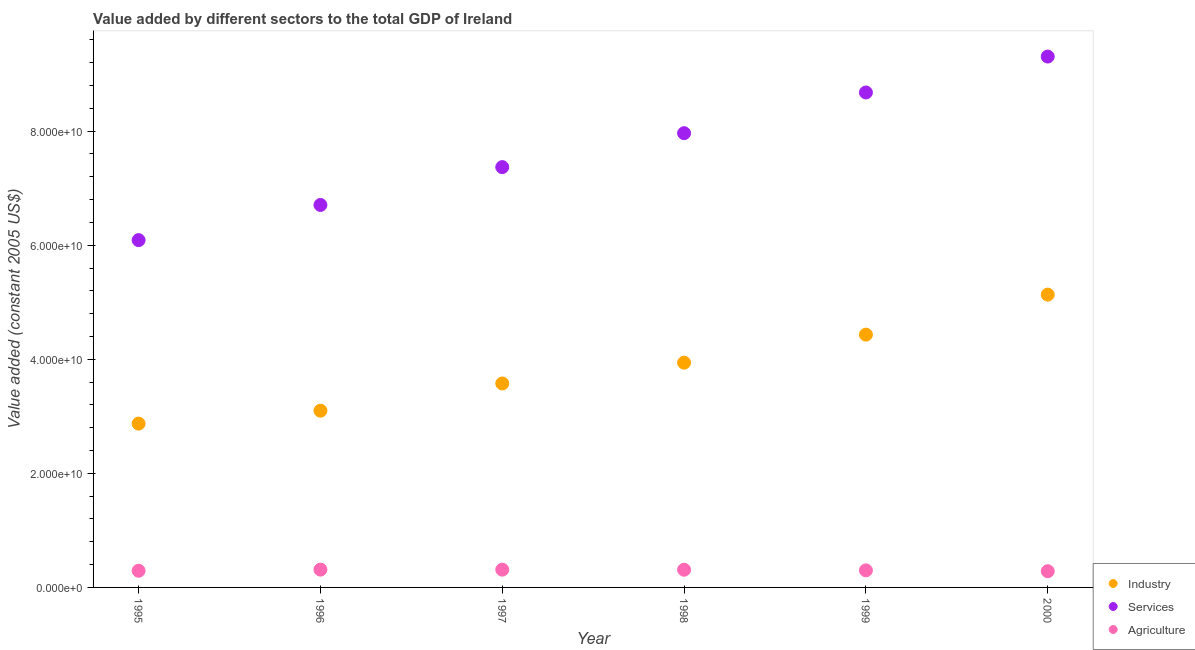What is the value added by industrial sector in 1995?
Provide a succinct answer. 2.87e+1. Across all years, what is the maximum value added by agricultural sector?
Offer a terse response. 3.12e+09. Across all years, what is the minimum value added by services?
Offer a terse response. 6.09e+1. What is the total value added by services in the graph?
Your answer should be compact. 4.61e+11. What is the difference between the value added by industrial sector in 1997 and that in 2000?
Your response must be concise. -1.56e+1. What is the difference between the value added by services in 1998 and the value added by agricultural sector in 1996?
Your answer should be compact. 7.65e+1. What is the average value added by industrial sector per year?
Provide a short and direct response. 3.84e+1. In the year 1995, what is the difference between the value added by industrial sector and value added by services?
Your answer should be very brief. -3.22e+1. In how many years, is the value added by agricultural sector greater than 4000000000 US$?
Give a very brief answer. 0. What is the ratio of the value added by agricultural sector in 1995 to that in 1997?
Ensure brevity in your answer.  0.94. What is the difference between the highest and the second highest value added by industrial sector?
Offer a terse response. 7.01e+09. What is the difference between the highest and the lowest value added by services?
Your response must be concise. 3.22e+1. In how many years, is the value added by services greater than the average value added by services taken over all years?
Your answer should be very brief. 3. Is it the case that in every year, the sum of the value added by industrial sector and value added by services is greater than the value added by agricultural sector?
Make the answer very short. Yes. Does the value added by services monotonically increase over the years?
Offer a very short reply. Yes. Is the value added by industrial sector strictly greater than the value added by agricultural sector over the years?
Your response must be concise. Yes. How many years are there in the graph?
Make the answer very short. 6. What is the difference between two consecutive major ticks on the Y-axis?
Make the answer very short. 2.00e+1. How many legend labels are there?
Your answer should be compact. 3. How are the legend labels stacked?
Your answer should be very brief. Vertical. What is the title of the graph?
Provide a succinct answer. Value added by different sectors to the total GDP of Ireland. What is the label or title of the X-axis?
Keep it short and to the point. Year. What is the label or title of the Y-axis?
Keep it short and to the point. Value added (constant 2005 US$). What is the Value added (constant 2005 US$) in Industry in 1995?
Ensure brevity in your answer.  2.87e+1. What is the Value added (constant 2005 US$) of Services in 1995?
Your answer should be very brief. 6.09e+1. What is the Value added (constant 2005 US$) of Agriculture in 1995?
Keep it short and to the point. 2.92e+09. What is the Value added (constant 2005 US$) in Industry in 1996?
Your answer should be very brief. 3.10e+1. What is the Value added (constant 2005 US$) in Services in 1996?
Provide a succinct answer. 6.71e+1. What is the Value added (constant 2005 US$) in Agriculture in 1996?
Offer a terse response. 3.12e+09. What is the Value added (constant 2005 US$) in Industry in 1997?
Your answer should be compact. 3.58e+1. What is the Value added (constant 2005 US$) in Services in 1997?
Keep it short and to the point. 7.37e+1. What is the Value added (constant 2005 US$) of Agriculture in 1997?
Provide a short and direct response. 3.12e+09. What is the Value added (constant 2005 US$) of Industry in 1998?
Your answer should be very brief. 3.94e+1. What is the Value added (constant 2005 US$) of Services in 1998?
Give a very brief answer. 7.96e+1. What is the Value added (constant 2005 US$) in Agriculture in 1998?
Your answer should be compact. 3.10e+09. What is the Value added (constant 2005 US$) in Industry in 1999?
Keep it short and to the point. 4.43e+1. What is the Value added (constant 2005 US$) of Services in 1999?
Ensure brevity in your answer.  8.68e+1. What is the Value added (constant 2005 US$) of Agriculture in 1999?
Offer a very short reply. 2.99e+09. What is the Value added (constant 2005 US$) in Industry in 2000?
Provide a succinct answer. 5.13e+1. What is the Value added (constant 2005 US$) in Services in 2000?
Provide a succinct answer. 9.31e+1. What is the Value added (constant 2005 US$) of Agriculture in 2000?
Your response must be concise. 2.85e+09. Across all years, what is the maximum Value added (constant 2005 US$) in Industry?
Provide a short and direct response. 5.13e+1. Across all years, what is the maximum Value added (constant 2005 US$) in Services?
Ensure brevity in your answer.  9.31e+1. Across all years, what is the maximum Value added (constant 2005 US$) in Agriculture?
Your answer should be very brief. 3.12e+09. Across all years, what is the minimum Value added (constant 2005 US$) in Industry?
Provide a succinct answer. 2.87e+1. Across all years, what is the minimum Value added (constant 2005 US$) of Services?
Provide a short and direct response. 6.09e+1. Across all years, what is the minimum Value added (constant 2005 US$) of Agriculture?
Provide a succinct answer. 2.85e+09. What is the total Value added (constant 2005 US$) in Industry in the graph?
Your response must be concise. 2.31e+11. What is the total Value added (constant 2005 US$) in Services in the graph?
Give a very brief answer. 4.61e+11. What is the total Value added (constant 2005 US$) of Agriculture in the graph?
Your answer should be very brief. 1.81e+1. What is the difference between the Value added (constant 2005 US$) of Industry in 1995 and that in 1996?
Provide a short and direct response. -2.26e+09. What is the difference between the Value added (constant 2005 US$) of Services in 1995 and that in 1996?
Offer a very short reply. -6.16e+09. What is the difference between the Value added (constant 2005 US$) of Agriculture in 1995 and that in 1996?
Offer a terse response. -2.00e+08. What is the difference between the Value added (constant 2005 US$) in Industry in 1995 and that in 1997?
Keep it short and to the point. -7.04e+09. What is the difference between the Value added (constant 2005 US$) of Services in 1995 and that in 1997?
Make the answer very short. -1.28e+1. What is the difference between the Value added (constant 2005 US$) of Agriculture in 1995 and that in 1997?
Offer a very short reply. -1.97e+08. What is the difference between the Value added (constant 2005 US$) of Industry in 1995 and that in 1998?
Your answer should be very brief. -1.07e+1. What is the difference between the Value added (constant 2005 US$) of Services in 1995 and that in 1998?
Give a very brief answer. -1.87e+1. What is the difference between the Value added (constant 2005 US$) of Agriculture in 1995 and that in 1998?
Your answer should be compact. -1.81e+08. What is the difference between the Value added (constant 2005 US$) in Industry in 1995 and that in 1999?
Offer a very short reply. -1.56e+1. What is the difference between the Value added (constant 2005 US$) of Services in 1995 and that in 1999?
Give a very brief answer. -2.59e+1. What is the difference between the Value added (constant 2005 US$) in Agriculture in 1995 and that in 1999?
Keep it short and to the point. -7.07e+07. What is the difference between the Value added (constant 2005 US$) in Industry in 1995 and that in 2000?
Give a very brief answer. -2.26e+1. What is the difference between the Value added (constant 2005 US$) of Services in 1995 and that in 2000?
Give a very brief answer. -3.22e+1. What is the difference between the Value added (constant 2005 US$) in Agriculture in 1995 and that in 2000?
Offer a very short reply. 7.59e+07. What is the difference between the Value added (constant 2005 US$) of Industry in 1996 and that in 1997?
Keep it short and to the point. -4.77e+09. What is the difference between the Value added (constant 2005 US$) in Services in 1996 and that in 1997?
Give a very brief answer. -6.64e+09. What is the difference between the Value added (constant 2005 US$) in Agriculture in 1996 and that in 1997?
Keep it short and to the point. 3.65e+06. What is the difference between the Value added (constant 2005 US$) of Industry in 1996 and that in 1998?
Your response must be concise. -8.42e+09. What is the difference between the Value added (constant 2005 US$) in Services in 1996 and that in 1998?
Offer a very short reply. -1.26e+1. What is the difference between the Value added (constant 2005 US$) of Agriculture in 1996 and that in 1998?
Ensure brevity in your answer.  1.94e+07. What is the difference between the Value added (constant 2005 US$) in Industry in 1996 and that in 1999?
Give a very brief answer. -1.33e+1. What is the difference between the Value added (constant 2005 US$) of Services in 1996 and that in 1999?
Offer a very short reply. -1.97e+1. What is the difference between the Value added (constant 2005 US$) of Agriculture in 1996 and that in 1999?
Make the answer very short. 1.30e+08. What is the difference between the Value added (constant 2005 US$) in Industry in 1996 and that in 2000?
Provide a short and direct response. -2.03e+1. What is the difference between the Value added (constant 2005 US$) of Services in 1996 and that in 2000?
Make the answer very short. -2.60e+1. What is the difference between the Value added (constant 2005 US$) in Agriculture in 1996 and that in 2000?
Your answer should be compact. 2.76e+08. What is the difference between the Value added (constant 2005 US$) of Industry in 1997 and that in 1998?
Your response must be concise. -3.65e+09. What is the difference between the Value added (constant 2005 US$) in Services in 1997 and that in 1998?
Keep it short and to the point. -5.95e+09. What is the difference between the Value added (constant 2005 US$) in Agriculture in 1997 and that in 1998?
Provide a short and direct response. 1.58e+07. What is the difference between the Value added (constant 2005 US$) of Industry in 1997 and that in 1999?
Make the answer very short. -8.56e+09. What is the difference between the Value added (constant 2005 US$) in Services in 1997 and that in 1999?
Give a very brief answer. -1.31e+1. What is the difference between the Value added (constant 2005 US$) in Agriculture in 1997 and that in 1999?
Give a very brief answer. 1.26e+08. What is the difference between the Value added (constant 2005 US$) of Industry in 1997 and that in 2000?
Provide a succinct answer. -1.56e+1. What is the difference between the Value added (constant 2005 US$) in Services in 1997 and that in 2000?
Your answer should be compact. -1.94e+1. What is the difference between the Value added (constant 2005 US$) of Agriculture in 1997 and that in 2000?
Offer a very short reply. 2.72e+08. What is the difference between the Value added (constant 2005 US$) in Industry in 1998 and that in 1999?
Your answer should be very brief. -4.91e+09. What is the difference between the Value added (constant 2005 US$) in Services in 1998 and that in 1999?
Your answer should be compact. -7.14e+09. What is the difference between the Value added (constant 2005 US$) in Agriculture in 1998 and that in 1999?
Give a very brief answer. 1.10e+08. What is the difference between the Value added (constant 2005 US$) of Industry in 1998 and that in 2000?
Keep it short and to the point. -1.19e+1. What is the difference between the Value added (constant 2005 US$) of Services in 1998 and that in 2000?
Make the answer very short. -1.34e+1. What is the difference between the Value added (constant 2005 US$) of Agriculture in 1998 and that in 2000?
Your response must be concise. 2.57e+08. What is the difference between the Value added (constant 2005 US$) of Industry in 1999 and that in 2000?
Keep it short and to the point. -7.01e+09. What is the difference between the Value added (constant 2005 US$) in Services in 1999 and that in 2000?
Ensure brevity in your answer.  -6.30e+09. What is the difference between the Value added (constant 2005 US$) of Agriculture in 1999 and that in 2000?
Provide a succinct answer. 1.47e+08. What is the difference between the Value added (constant 2005 US$) of Industry in 1995 and the Value added (constant 2005 US$) of Services in 1996?
Provide a short and direct response. -3.83e+1. What is the difference between the Value added (constant 2005 US$) in Industry in 1995 and the Value added (constant 2005 US$) in Agriculture in 1996?
Provide a short and direct response. 2.56e+1. What is the difference between the Value added (constant 2005 US$) in Services in 1995 and the Value added (constant 2005 US$) in Agriculture in 1996?
Make the answer very short. 5.78e+1. What is the difference between the Value added (constant 2005 US$) of Industry in 1995 and the Value added (constant 2005 US$) of Services in 1997?
Your answer should be compact. -4.50e+1. What is the difference between the Value added (constant 2005 US$) of Industry in 1995 and the Value added (constant 2005 US$) of Agriculture in 1997?
Keep it short and to the point. 2.56e+1. What is the difference between the Value added (constant 2005 US$) of Services in 1995 and the Value added (constant 2005 US$) of Agriculture in 1997?
Ensure brevity in your answer.  5.78e+1. What is the difference between the Value added (constant 2005 US$) of Industry in 1995 and the Value added (constant 2005 US$) of Services in 1998?
Your answer should be compact. -5.09e+1. What is the difference between the Value added (constant 2005 US$) in Industry in 1995 and the Value added (constant 2005 US$) in Agriculture in 1998?
Your answer should be very brief. 2.56e+1. What is the difference between the Value added (constant 2005 US$) in Services in 1995 and the Value added (constant 2005 US$) in Agriculture in 1998?
Ensure brevity in your answer.  5.78e+1. What is the difference between the Value added (constant 2005 US$) of Industry in 1995 and the Value added (constant 2005 US$) of Services in 1999?
Offer a terse response. -5.81e+1. What is the difference between the Value added (constant 2005 US$) of Industry in 1995 and the Value added (constant 2005 US$) of Agriculture in 1999?
Provide a short and direct response. 2.57e+1. What is the difference between the Value added (constant 2005 US$) of Services in 1995 and the Value added (constant 2005 US$) of Agriculture in 1999?
Ensure brevity in your answer.  5.79e+1. What is the difference between the Value added (constant 2005 US$) of Industry in 1995 and the Value added (constant 2005 US$) of Services in 2000?
Provide a succinct answer. -6.44e+1. What is the difference between the Value added (constant 2005 US$) in Industry in 1995 and the Value added (constant 2005 US$) in Agriculture in 2000?
Give a very brief answer. 2.59e+1. What is the difference between the Value added (constant 2005 US$) of Services in 1995 and the Value added (constant 2005 US$) of Agriculture in 2000?
Offer a very short reply. 5.80e+1. What is the difference between the Value added (constant 2005 US$) in Industry in 1996 and the Value added (constant 2005 US$) in Services in 1997?
Give a very brief answer. -4.27e+1. What is the difference between the Value added (constant 2005 US$) in Industry in 1996 and the Value added (constant 2005 US$) in Agriculture in 1997?
Make the answer very short. 2.79e+1. What is the difference between the Value added (constant 2005 US$) of Services in 1996 and the Value added (constant 2005 US$) of Agriculture in 1997?
Provide a short and direct response. 6.39e+1. What is the difference between the Value added (constant 2005 US$) in Industry in 1996 and the Value added (constant 2005 US$) in Services in 1998?
Provide a succinct answer. -4.87e+1. What is the difference between the Value added (constant 2005 US$) in Industry in 1996 and the Value added (constant 2005 US$) in Agriculture in 1998?
Keep it short and to the point. 2.79e+1. What is the difference between the Value added (constant 2005 US$) of Services in 1996 and the Value added (constant 2005 US$) of Agriculture in 1998?
Your answer should be compact. 6.40e+1. What is the difference between the Value added (constant 2005 US$) of Industry in 1996 and the Value added (constant 2005 US$) of Services in 1999?
Offer a very short reply. -5.58e+1. What is the difference between the Value added (constant 2005 US$) of Industry in 1996 and the Value added (constant 2005 US$) of Agriculture in 1999?
Provide a short and direct response. 2.80e+1. What is the difference between the Value added (constant 2005 US$) of Services in 1996 and the Value added (constant 2005 US$) of Agriculture in 1999?
Offer a terse response. 6.41e+1. What is the difference between the Value added (constant 2005 US$) of Industry in 1996 and the Value added (constant 2005 US$) of Services in 2000?
Give a very brief answer. -6.21e+1. What is the difference between the Value added (constant 2005 US$) of Industry in 1996 and the Value added (constant 2005 US$) of Agriculture in 2000?
Make the answer very short. 2.81e+1. What is the difference between the Value added (constant 2005 US$) in Services in 1996 and the Value added (constant 2005 US$) in Agriculture in 2000?
Offer a very short reply. 6.42e+1. What is the difference between the Value added (constant 2005 US$) in Industry in 1997 and the Value added (constant 2005 US$) in Services in 1998?
Your answer should be compact. -4.39e+1. What is the difference between the Value added (constant 2005 US$) in Industry in 1997 and the Value added (constant 2005 US$) in Agriculture in 1998?
Give a very brief answer. 3.27e+1. What is the difference between the Value added (constant 2005 US$) in Services in 1997 and the Value added (constant 2005 US$) in Agriculture in 1998?
Keep it short and to the point. 7.06e+1. What is the difference between the Value added (constant 2005 US$) of Industry in 1997 and the Value added (constant 2005 US$) of Services in 1999?
Your answer should be very brief. -5.10e+1. What is the difference between the Value added (constant 2005 US$) in Industry in 1997 and the Value added (constant 2005 US$) in Agriculture in 1999?
Your answer should be compact. 3.28e+1. What is the difference between the Value added (constant 2005 US$) in Services in 1997 and the Value added (constant 2005 US$) in Agriculture in 1999?
Offer a terse response. 7.07e+1. What is the difference between the Value added (constant 2005 US$) of Industry in 1997 and the Value added (constant 2005 US$) of Services in 2000?
Ensure brevity in your answer.  -5.73e+1. What is the difference between the Value added (constant 2005 US$) in Industry in 1997 and the Value added (constant 2005 US$) in Agriculture in 2000?
Keep it short and to the point. 3.29e+1. What is the difference between the Value added (constant 2005 US$) in Services in 1997 and the Value added (constant 2005 US$) in Agriculture in 2000?
Give a very brief answer. 7.08e+1. What is the difference between the Value added (constant 2005 US$) in Industry in 1998 and the Value added (constant 2005 US$) in Services in 1999?
Your answer should be very brief. -4.74e+1. What is the difference between the Value added (constant 2005 US$) in Industry in 1998 and the Value added (constant 2005 US$) in Agriculture in 1999?
Give a very brief answer. 3.64e+1. What is the difference between the Value added (constant 2005 US$) in Services in 1998 and the Value added (constant 2005 US$) in Agriculture in 1999?
Provide a short and direct response. 7.67e+1. What is the difference between the Value added (constant 2005 US$) of Industry in 1998 and the Value added (constant 2005 US$) of Services in 2000?
Provide a short and direct response. -5.37e+1. What is the difference between the Value added (constant 2005 US$) in Industry in 1998 and the Value added (constant 2005 US$) in Agriculture in 2000?
Provide a succinct answer. 3.66e+1. What is the difference between the Value added (constant 2005 US$) of Services in 1998 and the Value added (constant 2005 US$) of Agriculture in 2000?
Your answer should be very brief. 7.68e+1. What is the difference between the Value added (constant 2005 US$) of Industry in 1999 and the Value added (constant 2005 US$) of Services in 2000?
Your answer should be compact. -4.88e+1. What is the difference between the Value added (constant 2005 US$) of Industry in 1999 and the Value added (constant 2005 US$) of Agriculture in 2000?
Give a very brief answer. 4.15e+1. What is the difference between the Value added (constant 2005 US$) of Services in 1999 and the Value added (constant 2005 US$) of Agriculture in 2000?
Make the answer very short. 8.39e+1. What is the average Value added (constant 2005 US$) of Industry per year?
Offer a very short reply. 3.84e+1. What is the average Value added (constant 2005 US$) in Services per year?
Offer a terse response. 7.69e+1. What is the average Value added (constant 2005 US$) in Agriculture per year?
Provide a short and direct response. 3.02e+09. In the year 1995, what is the difference between the Value added (constant 2005 US$) in Industry and Value added (constant 2005 US$) in Services?
Make the answer very short. -3.22e+1. In the year 1995, what is the difference between the Value added (constant 2005 US$) in Industry and Value added (constant 2005 US$) in Agriculture?
Ensure brevity in your answer.  2.58e+1. In the year 1995, what is the difference between the Value added (constant 2005 US$) of Services and Value added (constant 2005 US$) of Agriculture?
Ensure brevity in your answer.  5.80e+1. In the year 1996, what is the difference between the Value added (constant 2005 US$) in Industry and Value added (constant 2005 US$) in Services?
Offer a very short reply. -3.61e+1. In the year 1996, what is the difference between the Value added (constant 2005 US$) in Industry and Value added (constant 2005 US$) in Agriculture?
Your answer should be very brief. 2.79e+1. In the year 1996, what is the difference between the Value added (constant 2005 US$) of Services and Value added (constant 2005 US$) of Agriculture?
Offer a terse response. 6.39e+1. In the year 1997, what is the difference between the Value added (constant 2005 US$) in Industry and Value added (constant 2005 US$) in Services?
Your answer should be compact. -3.79e+1. In the year 1997, what is the difference between the Value added (constant 2005 US$) of Industry and Value added (constant 2005 US$) of Agriculture?
Keep it short and to the point. 3.26e+1. In the year 1997, what is the difference between the Value added (constant 2005 US$) in Services and Value added (constant 2005 US$) in Agriculture?
Offer a very short reply. 7.06e+1. In the year 1998, what is the difference between the Value added (constant 2005 US$) in Industry and Value added (constant 2005 US$) in Services?
Your answer should be very brief. -4.02e+1. In the year 1998, what is the difference between the Value added (constant 2005 US$) of Industry and Value added (constant 2005 US$) of Agriculture?
Make the answer very short. 3.63e+1. In the year 1998, what is the difference between the Value added (constant 2005 US$) of Services and Value added (constant 2005 US$) of Agriculture?
Ensure brevity in your answer.  7.65e+1. In the year 1999, what is the difference between the Value added (constant 2005 US$) in Industry and Value added (constant 2005 US$) in Services?
Your response must be concise. -4.25e+1. In the year 1999, what is the difference between the Value added (constant 2005 US$) in Industry and Value added (constant 2005 US$) in Agriculture?
Your answer should be compact. 4.13e+1. In the year 1999, what is the difference between the Value added (constant 2005 US$) of Services and Value added (constant 2005 US$) of Agriculture?
Make the answer very short. 8.38e+1. In the year 2000, what is the difference between the Value added (constant 2005 US$) of Industry and Value added (constant 2005 US$) of Services?
Keep it short and to the point. -4.17e+1. In the year 2000, what is the difference between the Value added (constant 2005 US$) of Industry and Value added (constant 2005 US$) of Agriculture?
Your response must be concise. 4.85e+1. In the year 2000, what is the difference between the Value added (constant 2005 US$) in Services and Value added (constant 2005 US$) in Agriculture?
Provide a succinct answer. 9.02e+1. What is the ratio of the Value added (constant 2005 US$) of Industry in 1995 to that in 1996?
Keep it short and to the point. 0.93. What is the ratio of the Value added (constant 2005 US$) in Services in 1995 to that in 1996?
Your answer should be compact. 0.91. What is the ratio of the Value added (constant 2005 US$) in Agriculture in 1995 to that in 1996?
Give a very brief answer. 0.94. What is the ratio of the Value added (constant 2005 US$) in Industry in 1995 to that in 1997?
Offer a very short reply. 0.8. What is the ratio of the Value added (constant 2005 US$) in Services in 1995 to that in 1997?
Keep it short and to the point. 0.83. What is the ratio of the Value added (constant 2005 US$) of Agriculture in 1995 to that in 1997?
Offer a terse response. 0.94. What is the ratio of the Value added (constant 2005 US$) in Industry in 1995 to that in 1998?
Keep it short and to the point. 0.73. What is the ratio of the Value added (constant 2005 US$) of Services in 1995 to that in 1998?
Your answer should be compact. 0.76. What is the ratio of the Value added (constant 2005 US$) in Agriculture in 1995 to that in 1998?
Provide a succinct answer. 0.94. What is the ratio of the Value added (constant 2005 US$) in Industry in 1995 to that in 1999?
Make the answer very short. 0.65. What is the ratio of the Value added (constant 2005 US$) in Services in 1995 to that in 1999?
Ensure brevity in your answer.  0.7. What is the ratio of the Value added (constant 2005 US$) in Agriculture in 1995 to that in 1999?
Your answer should be compact. 0.98. What is the ratio of the Value added (constant 2005 US$) of Industry in 1995 to that in 2000?
Make the answer very short. 0.56. What is the ratio of the Value added (constant 2005 US$) of Services in 1995 to that in 2000?
Ensure brevity in your answer.  0.65. What is the ratio of the Value added (constant 2005 US$) in Agriculture in 1995 to that in 2000?
Your response must be concise. 1.03. What is the ratio of the Value added (constant 2005 US$) of Industry in 1996 to that in 1997?
Your response must be concise. 0.87. What is the ratio of the Value added (constant 2005 US$) in Services in 1996 to that in 1997?
Provide a succinct answer. 0.91. What is the ratio of the Value added (constant 2005 US$) in Agriculture in 1996 to that in 1997?
Offer a terse response. 1. What is the ratio of the Value added (constant 2005 US$) in Industry in 1996 to that in 1998?
Keep it short and to the point. 0.79. What is the ratio of the Value added (constant 2005 US$) of Services in 1996 to that in 1998?
Give a very brief answer. 0.84. What is the ratio of the Value added (constant 2005 US$) in Agriculture in 1996 to that in 1998?
Give a very brief answer. 1.01. What is the ratio of the Value added (constant 2005 US$) in Industry in 1996 to that in 1999?
Ensure brevity in your answer.  0.7. What is the ratio of the Value added (constant 2005 US$) in Services in 1996 to that in 1999?
Keep it short and to the point. 0.77. What is the ratio of the Value added (constant 2005 US$) of Agriculture in 1996 to that in 1999?
Make the answer very short. 1.04. What is the ratio of the Value added (constant 2005 US$) in Industry in 1996 to that in 2000?
Keep it short and to the point. 0.6. What is the ratio of the Value added (constant 2005 US$) of Services in 1996 to that in 2000?
Offer a very short reply. 0.72. What is the ratio of the Value added (constant 2005 US$) of Agriculture in 1996 to that in 2000?
Your answer should be compact. 1.1. What is the ratio of the Value added (constant 2005 US$) in Industry in 1997 to that in 1998?
Provide a succinct answer. 0.91. What is the ratio of the Value added (constant 2005 US$) in Services in 1997 to that in 1998?
Offer a very short reply. 0.93. What is the ratio of the Value added (constant 2005 US$) in Industry in 1997 to that in 1999?
Provide a short and direct response. 0.81. What is the ratio of the Value added (constant 2005 US$) in Services in 1997 to that in 1999?
Provide a succinct answer. 0.85. What is the ratio of the Value added (constant 2005 US$) of Agriculture in 1997 to that in 1999?
Ensure brevity in your answer.  1.04. What is the ratio of the Value added (constant 2005 US$) in Industry in 1997 to that in 2000?
Make the answer very short. 0.7. What is the ratio of the Value added (constant 2005 US$) in Services in 1997 to that in 2000?
Offer a terse response. 0.79. What is the ratio of the Value added (constant 2005 US$) in Agriculture in 1997 to that in 2000?
Make the answer very short. 1.1. What is the ratio of the Value added (constant 2005 US$) in Industry in 1998 to that in 1999?
Provide a succinct answer. 0.89. What is the ratio of the Value added (constant 2005 US$) of Services in 1998 to that in 1999?
Offer a terse response. 0.92. What is the ratio of the Value added (constant 2005 US$) of Agriculture in 1998 to that in 1999?
Ensure brevity in your answer.  1.04. What is the ratio of the Value added (constant 2005 US$) of Industry in 1998 to that in 2000?
Provide a succinct answer. 0.77. What is the ratio of the Value added (constant 2005 US$) in Services in 1998 to that in 2000?
Your response must be concise. 0.86. What is the ratio of the Value added (constant 2005 US$) in Agriculture in 1998 to that in 2000?
Provide a short and direct response. 1.09. What is the ratio of the Value added (constant 2005 US$) in Industry in 1999 to that in 2000?
Give a very brief answer. 0.86. What is the ratio of the Value added (constant 2005 US$) in Services in 1999 to that in 2000?
Offer a terse response. 0.93. What is the ratio of the Value added (constant 2005 US$) of Agriculture in 1999 to that in 2000?
Your answer should be very brief. 1.05. What is the difference between the highest and the second highest Value added (constant 2005 US$) of Industry?
Give a very brief answer. 7.01e+09. What is the difference between the highest and the second highest Value added (constant 2005 US$) in Services?
Ensure brevity in your answer.  6.30e+09. What is the difference between the highest and the second highest Value added (constant 2005 US$) of Agriculture?
Ensure brevity in your answer.  3.65e+06. What is the difference between the highest and the lowest Value added (constant 2005 US$) of Industry?
Make the answer very short. 2.26e+1. What is the difference between the highest and the lowest Value added (constant 2005 US$) of Services?
Your answer should be compact. 3.22e+1. What is the difference between the highest and the lowest Value added (constant 2005 US$) of Agriculture?
Your response must be concise. 2.76e+08. 